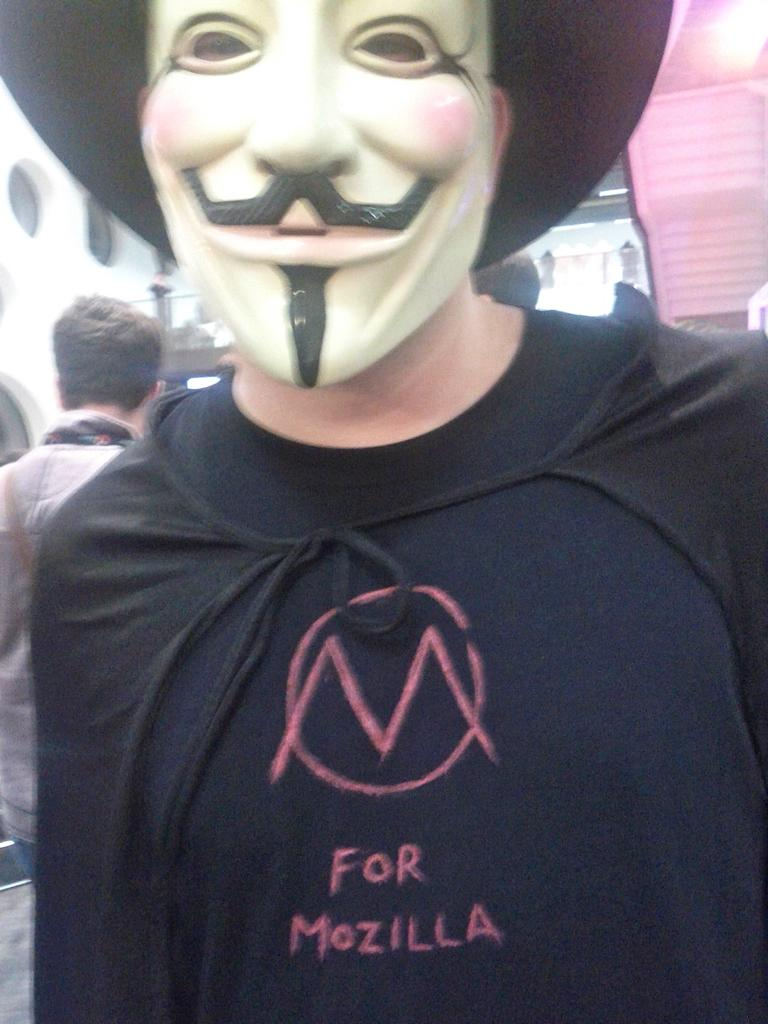What is the person in the image wearing? The person in the image is wearing a costume. Can you describe the other person in the image? There is another person standing behind the person in the costume. What can be seen in the background of the image? There is a white building visible in the background of the image. What color is the crayon being used by the person in the costume? There is no crayon present in the image, so it cannot be determined what color it might be. 